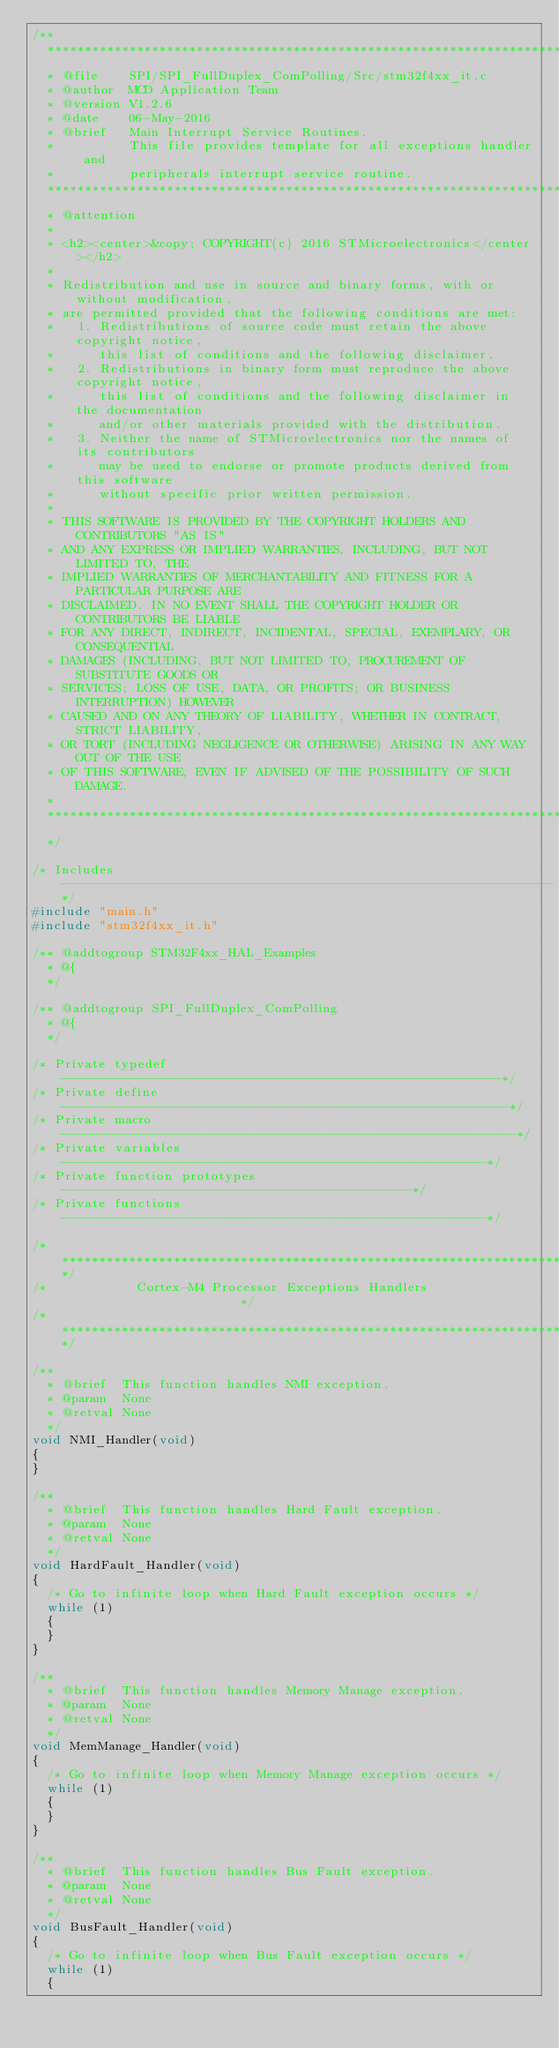Convert code to text. <code><loc_0><loc_0><loc_500><loc_500><_C_>/**
  ******************************************************************************
  * @file    SPI/SPI_FullDuplex_ComPolling/Src/stm32f4xx_it.c 
  * @author  MCD Application Team
  * @version V1.2.6
  * @date    06-May-2016 
  * @brief   Main Interrupt Service Routines.
  *          This file provides template for all exceptions handler and 
  *          peripherals interrupt service routine.
  ******************************************************************************
  * @attention
  *
  * <h2><center>&copy; COPYRIGHT(c) 2016 STMicroelectronics</center></h2>
  *
  * Redistribution and use in source and binary forms, with or without modification,
  * are permitted provided that the following conditions are met:
  *   1. Redistributions of source code must retain the above copyright notice,
  *      this list of conditions and the following disclaimer.
  *   2. Redistributions in binary form must reproduce the above copyright notice,
  *      this list of conditions and the following disclaimer in the documentation
  *      and/or other materials provided with the distribution.
  *   3. Neither the name of STMicroelectronics nor the names of its contributors
  *      may be used to endorse or promote products derived from this software
  *      without specific prior written permission.
  *
  * THIS SOFTWARE IS PROVIDED BY THE COPYRIGHT HOLDERS AND CONTRIBUTORS "AS IS"
  * AND ANY EXPRESS OR IMPLIED WARRANTIES, INCLUDING, BUT NOT LIMITED TO, THE
  * IMPLIED WARRANTIES OF MERCHANTABILITY AND FITNESS FOR A PARTICULAR PURPOSE ARE
  * DISCLAIMED. IN NO EVENT SHALL THE COPYRIGHT HOLDER OR CONTRIBUTORS BE LIABLE
  * FOR ANY DIRECT, INDIRECT, INCIDENTAL, SPECIAL, EXEMPLARY, OR CONSEQUENTIAL
  * DAMAGES (INCLUDING, BUT NOT LIMITED TO, PROCUREMENT OF SUBSTITUTE GOODS OR
  * SERVICES; LOSS OF USE, DATA, OR PROFITS; OR BUSINESS INTERRUPTION) HOWEVER
  * CAUSED AND ON ANY THEORY OF LIABILITY, WHETHER IN CONTRACT, STRICT LIABILITY,
  * OR TORT (INCLUDING NEGLIGENCE OR OTHERWISE) ARISING IN ANY WAY OUT OF THE USE
  * OF THIS SOFTWARE, EVEN IF ADVISED OF THE POSSIBILITY OF SUCH DAMAGE.
  *
  ******************************************************************************
  */

/* Includes ------------------------------------------------------------------*/
#include "main.h"
#include "stm32f4xx_it.h"
   
/** @addtogroup STM32F4xx_HAL_Examples
  * @{
  */

/** @addtogroup SPI_FullDuplex_ComPolling
  * @{
  */

/* Private typedef -----------------------------------------------------------*/
/* Private define ------------------------------------------------------------*/
/* Private macro -------------------------------------------------------------*/
/* Private variables ---------------------------------------------------------*/
/* Private function prototypes -----------------------------------------------*/
/* Private functions ---------------------------------------------------------*/

/******************************************************************************/
/*            Cortex-M4 Processor Exceptions Handlers                         */
/******************************************************************************/

/**
  * @brief  This function handles NMI exception.
  * @param  None
  * @retval None
  */
void NMI_Handler(void)
{
}

/**
  * @brief  This function handles Hard Fault exception.
  * @param  None
  * @retval None
  */
void HardFault_Handler(void)
{
  /* Go to infinite loop when Hard Fault exception occurs */
  while (1)
  {
  }
}

/**
  * @brief  This function handles Memory Manage exception.
  * @param  None
  * @retval None
  */
void MemManage_Handler(void)
{
  /* Go to infinite loop when Memory Manage exception occurs */
  while (1)
  {
  }
}

/**
  * @brief  This function handles Bus Fault exception.
  * @param  None
  * @retval None
  */
void BusFault_Handler(void)
{
  /* Go to infinite loop when Bus Fault exception occurs */
  while (1)
  {</code> 